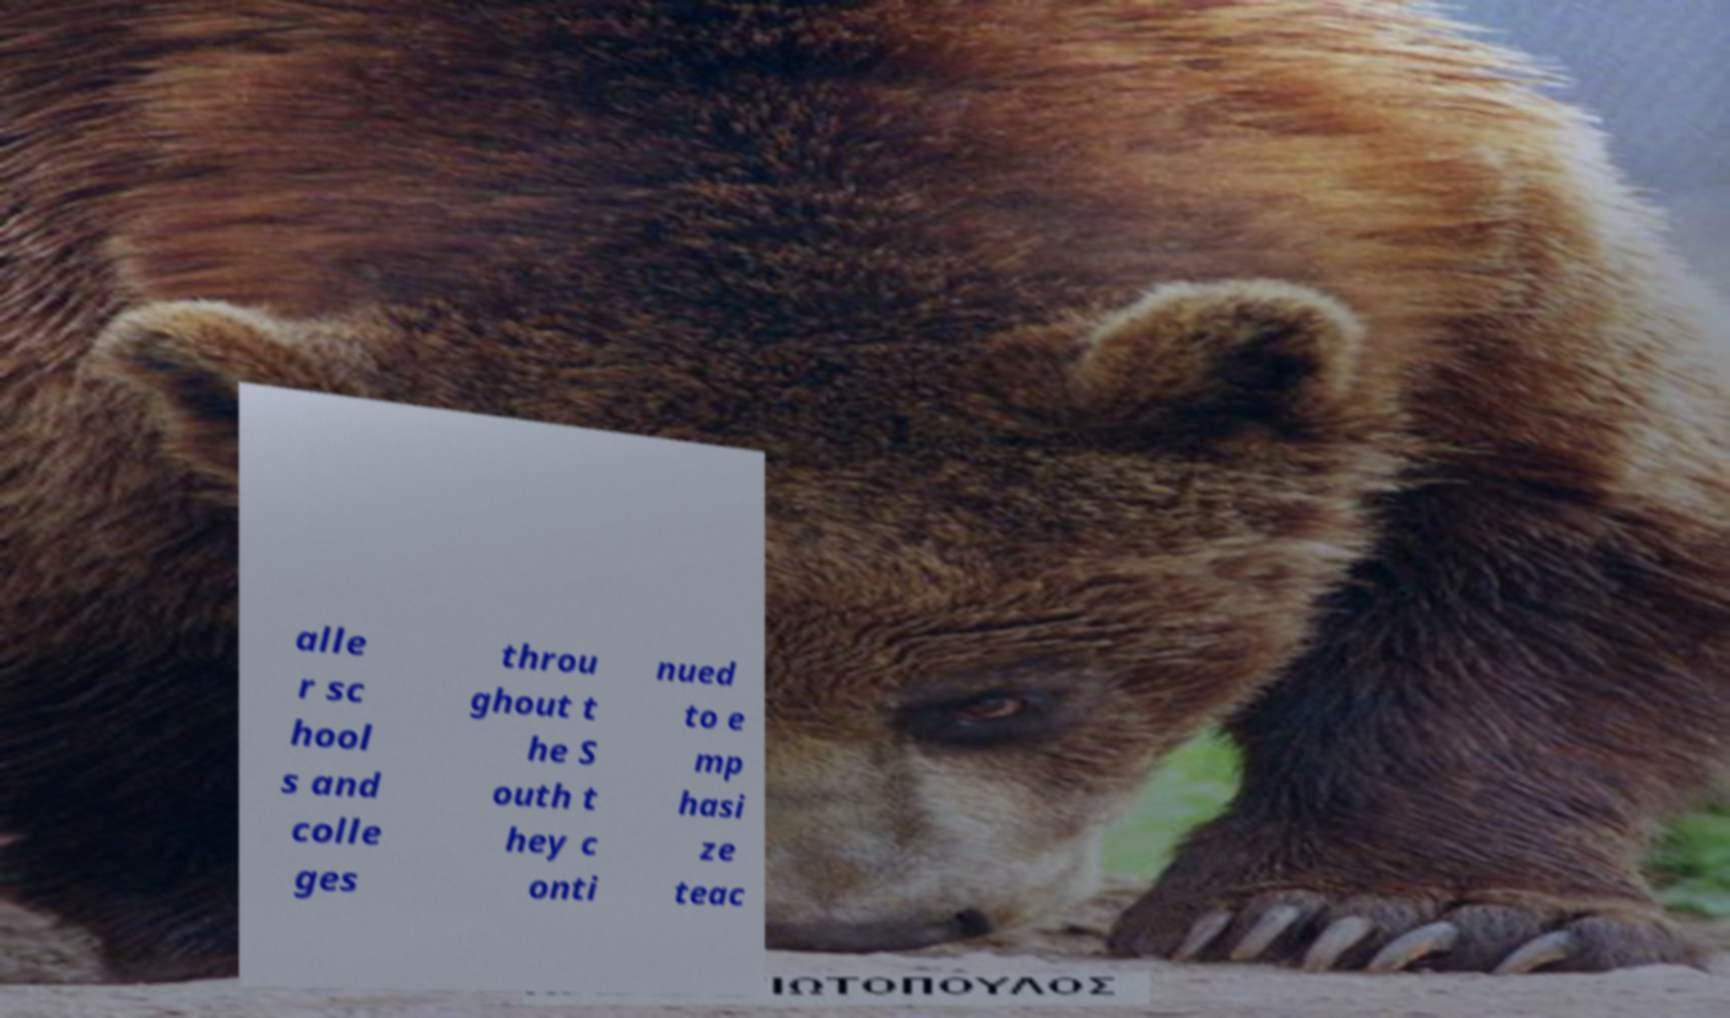There's text embedded in this image that I need extracted. Can you transcribe it verbatim? alle r sc hool s and colle ges throu ghout t he S outh t hey c onti nued to e mp hasi ze teac 